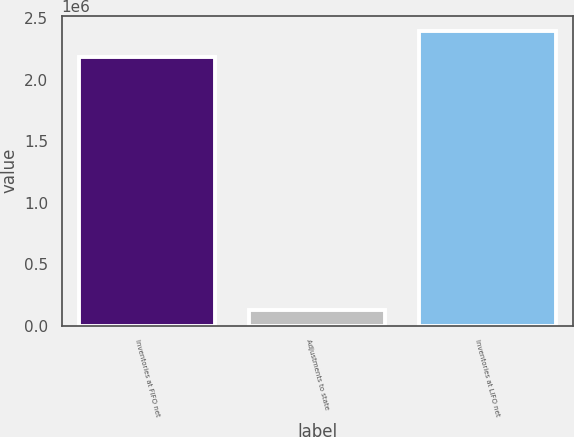Convert chart. <chart><loc_0><loc_0><loc_500><loc_500><bar_chart><fcel>Inventories at FIFO net<fcel>Adjustments to state<fcel>Inventories at LIFO net<nl><fcel>2.18242e+06<fcel>126190<fcel>2.40066e+06<nl></chart> 